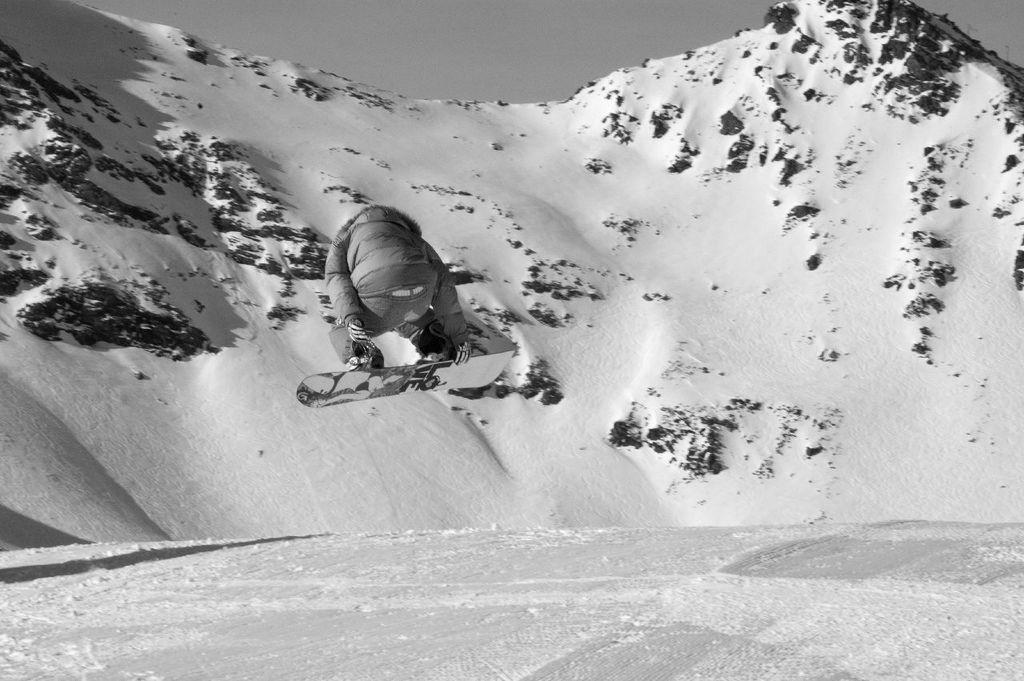Who is the main subject in the image? There is a person in the image. What is the person doing in the image? The person is jumping with a ski board. What can be seen in the background of the image? There is a mountain, snow, and the sky visible in the background of the image. How many giants are visible in the image? There are no giants present in the image. What type of seed is being planted by the person in the image? There is no seed or planting activity depicted in the image; the person is jumping with a ski board. 